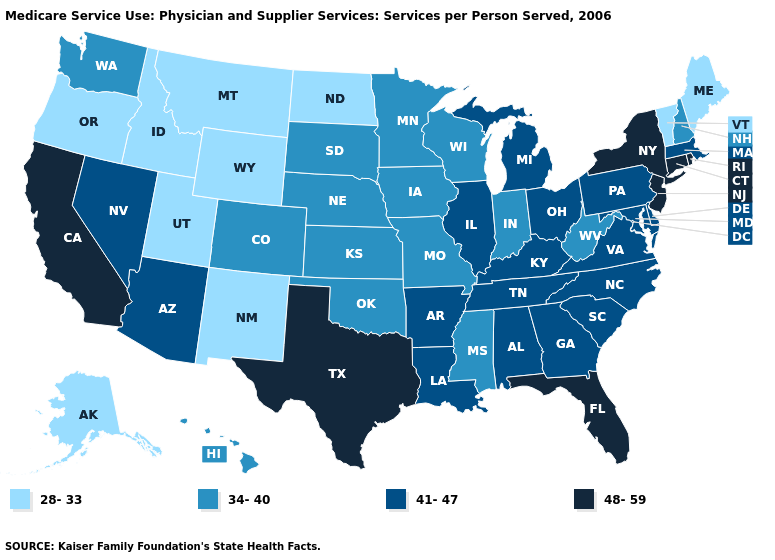What is the value of Nevada?
Be succinct. 41-47. Does Florida have a higher value than California?
Write a very short answer. No. Name the states that have a value in the range 41-47?
Concise answer only. Alabama, Arizona, Arkansas, Delaware, Georgia, Illinois, Kentucky, Louisiana, Maryland, Massachusetts, Michigan, Nevada, North Carolina, Ohio, Pennsylvania, South Carolina, Tennessee, Virginia. How many symbols are there in the legend?
Give a very brief answer. 4. What is the value of Alaska?
Keep it brief. 28-33. How many symbols are there in the legend?
Keep it brief. 4. Name the states that have a value in the range 41-47?
Write a very short answer. Alabama, Arizona, Arkansas, Delaware, Georgia, Illinois, Kentucky, Louisiana, Maryland, Massachusetts, Michigan, Nevada, North Carolina, Ohio, Pennsylvania, South Carolina, Tennessee, Virginia. What is the value of Hawaii?
Concise answer only. 34-40. Does Oregon have the lowest value in the USA?
Be succinct. Yes. Does Kansas have the highest value in the USA?
Write a very short answer. No. What is the value of Virginia?
Be succinct. 41-47. Which states have the highest value in the USA?
Keep it brief. California, Connecticut, Florida, New Jersey, New York, Rhode Island, Texas. Which states hav the highest value in the West?
Short answer required. California. What is the highest value in the USA?
Give a very brief answer. 48-59. Name the states that have a value in the range 28-33?
Keep it brief. Alaska, Idaho, Maine, Montana, New Mexico, North Dakota, Oregon, Utah, Vermont, Wyoming. 